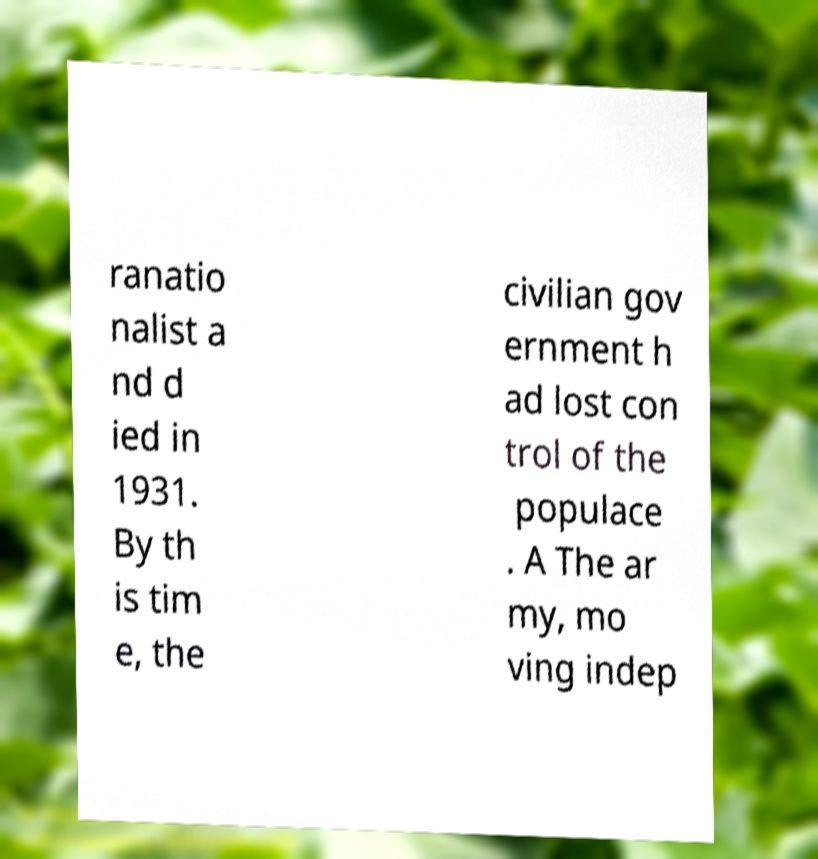Please identify and transcribe the text found in this image. ranatio nalist a nd d ied in 1931. By th is tim e, the civilian gov ernment h ad lost con trol of the populace . A The ar my, mo ving indep 